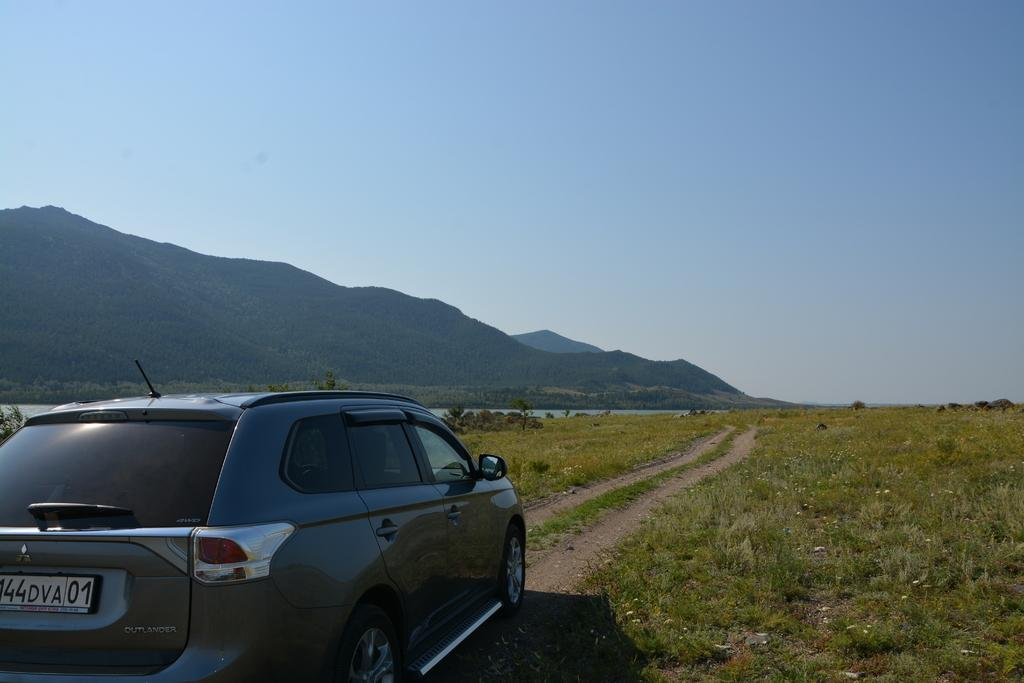What is on the path in the image? There is a car on the path in the image. What type of vegetation can be seen in the background of the image? There are plants with flowers, grass, and trees in the background of the image. What natural elements are visible in the background of the image? Water, hills, and the sky are visible in the background of the image. What type of berry is being used to answer the questions about the image? There is no berry present in the image, and berries are not used to answer questions about the image. 